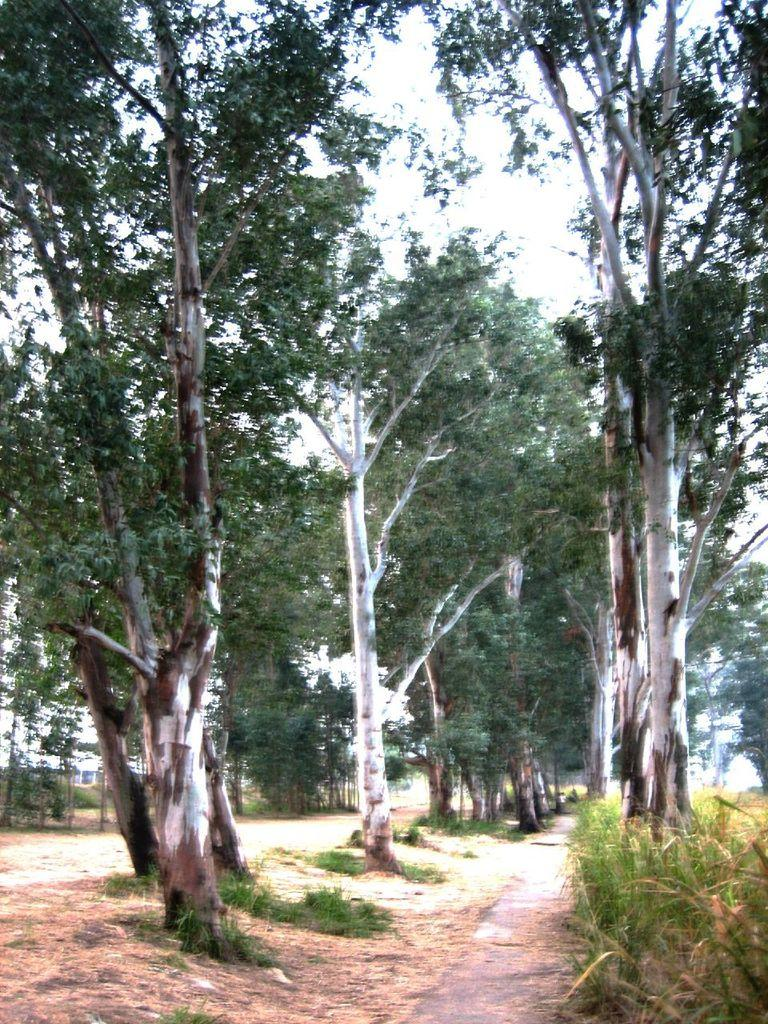What type of vegetation is visible in the image? There are many trees in the image. What can be seen in the image besides trees? There is a path and grass visible in the image. What is the color of the sky in the image? The sky is white in the image. What type of books can be seen being attacked by disgust in the image? There are no books or any indication of disgust present in the image. 